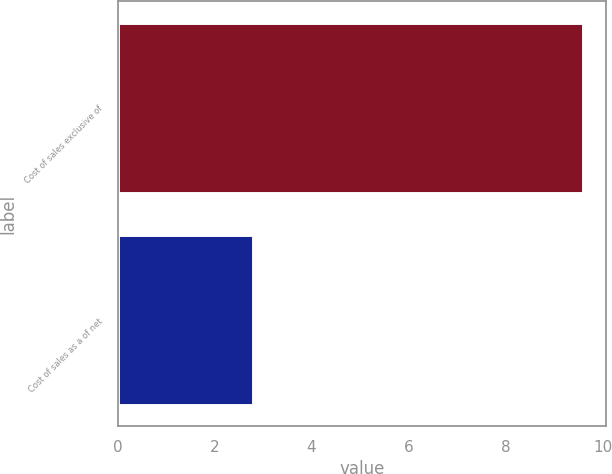Convert chart. <chart><loc_0><loc_0><loc_500><loc_500><bar_chart><fcel>Cost of sales exclusive of<fcel>Cost of sales as a of net<nl><fcel>9.6<fcel>2.8<nl></chart> 